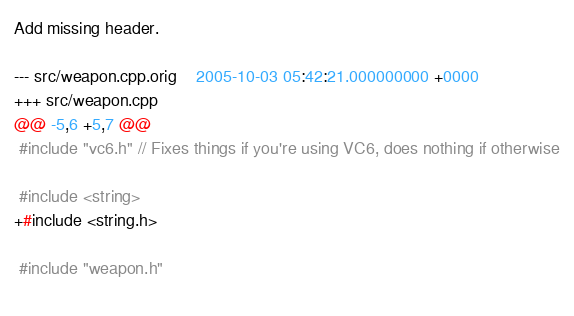<code> <loc_0><loc_0><loc_500><loc_500><_C++_>
Add missing header.

--- src/weapon.cpp.orig	2005-10-03 05:42:21.000000000 +0000
+++ src/weapon.cpp
@@ -5,6 +5,7 @@
 #include "vc6.h" // Fixes things if you're using VC6, does nothing if otherwise
 
 #include <string>
+#include <string.h>
 
 #include "weapon.h"
 
</code> 